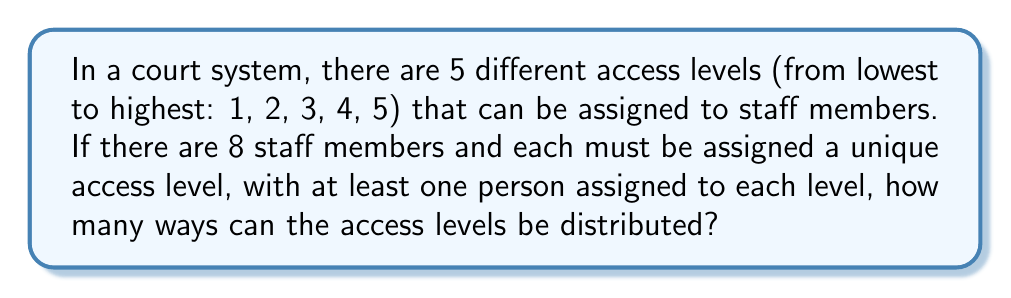Provide a solution to this math problem. Let's approach this step-by-step:

1) This is a problem of distributing 8 distinguishable objects (staff members) into 5 distinguishable boxes (access levels), with the condition that no box is empty.

2) This type of problem is solved using Stirling numbers of the second kind, denoted as $\stirling{n}{k}$, where n is the number of objects and k is the number of non-empty boxes.

3) The formula for Stirling numbers of the second kind is:

   $$\stirling{n}{k} = \frac{1}{k!}\sum_{i=0}^k (-1)^i \binom{k}{i}(k-i)^n$$

4) In our case, $n = 8$ and $k = 5$. So we need to calculate $\stirling{8}{5}$:

   $$\stirling{8}{5} = \frac{1}{5!}\sum_{i=0}^5 (-1)^i \binom{5}{i}(5-i)^8$$

5) Expanding this:
   
   $$\stirling{8}{5} = \frac{1}{120}[\binom{5}{0}5^8 - \binom{5}{1}4^8 + \binom{5}{2}3^8 - \binom{5}{3}2^8 + \binom{5}{4}1^8 - \binom{5}{5}0^8]$$

6) Calculating each term:
   
   $$\stirling{8}{5} = \frac{1}{120}[1 \cdot 390625 - 5 \cdot 65536 + 10 \cdot 6561 - 10 \cdot 256 + 5 \cdot 1 - 1 \cdot 0]$$
   
   $$= \frac{1}{120}[390625 - 327680 + 65610 - 2560 + 5]$$
   
   $$= \frac{126000}{120} = 1050$$

7) However, this only tells us how many ways to distribute 8 staff members into 5 access levels. To make each distribution unique, we need to multiply this by the number of ways to arrange 5 access levels, which is simply 5!.

8) Therefore, the final answer is:

   $$1050 \cdot 5! = 1050 \cdot 120 = 126000$$
Answer: 126000 